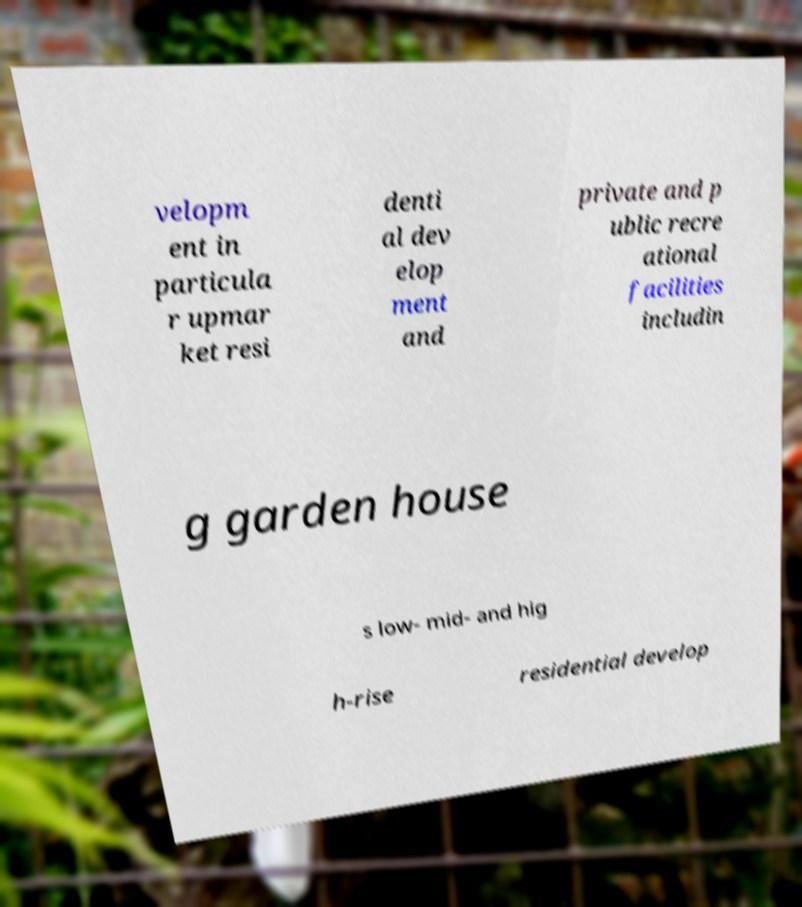Could you assist in decoding the text presented in this image and type it out clearly? velopm ent in particula r upmar ket resi denti al dev elop ment and private and p ublic recre ational facilities includin g garden house s low- mid- and hig h-rise residential develop 